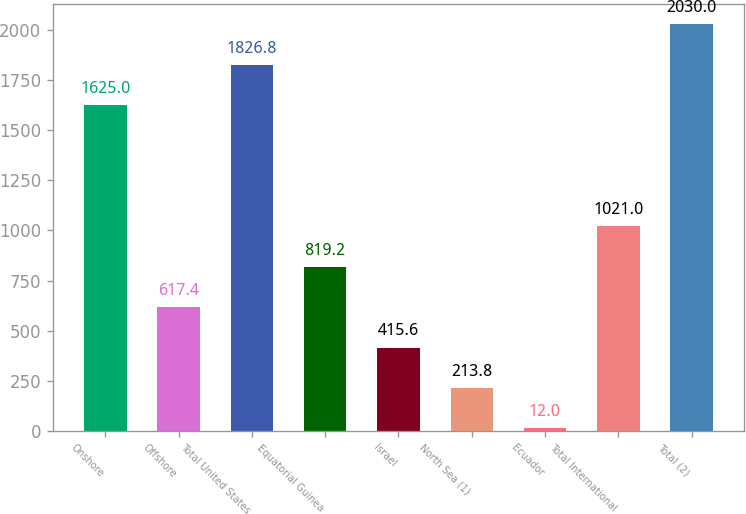Convert chart to OTSL. <chart><loc_0><loc_0><loc_500><loc_500><bar_chart><fcel>Onshore<fcel>Offshore<fcel>Total United States<fcel>Equatorial Guinea<fcel>Israel<fcel>North Sea (1)<fcel>Ecuador<fcel>Total International<fcel>Total (2)<nl><fcel>1625<fcel>617.4<fcel>1826.8<fcel>819.2<fcel>415.6<fcel>213.8<fcel>12<fcel>1021<fcel>2030<nl></chart> 